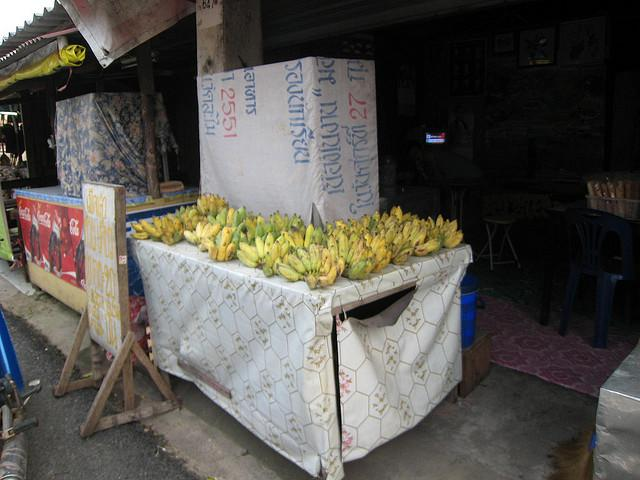What country produces a large number of these yellow food items?

Choices:
A) greenland
B) siberia
C) wessex
D) india india 